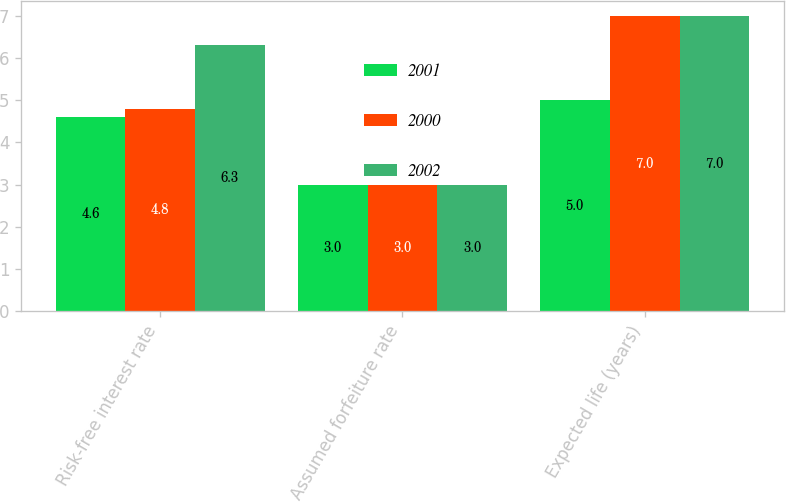Convert chart. <chart><loc_0><loc_0><loc_500><loc_500><stacked_bar_chart><ecel><fcel>Risk-free interest rate<fcel>Assumed forfeiture rate<fcel>Expected life (years)<nl><fcel>2001<fcel>4.6<fcel>3<fcel>5<nl><fcel>2000<fcel>4.8<fcel>3<fcel>7<nl><fcel>2002<fcel>6.3<fcel>3<fcel>7<nl></chart> 